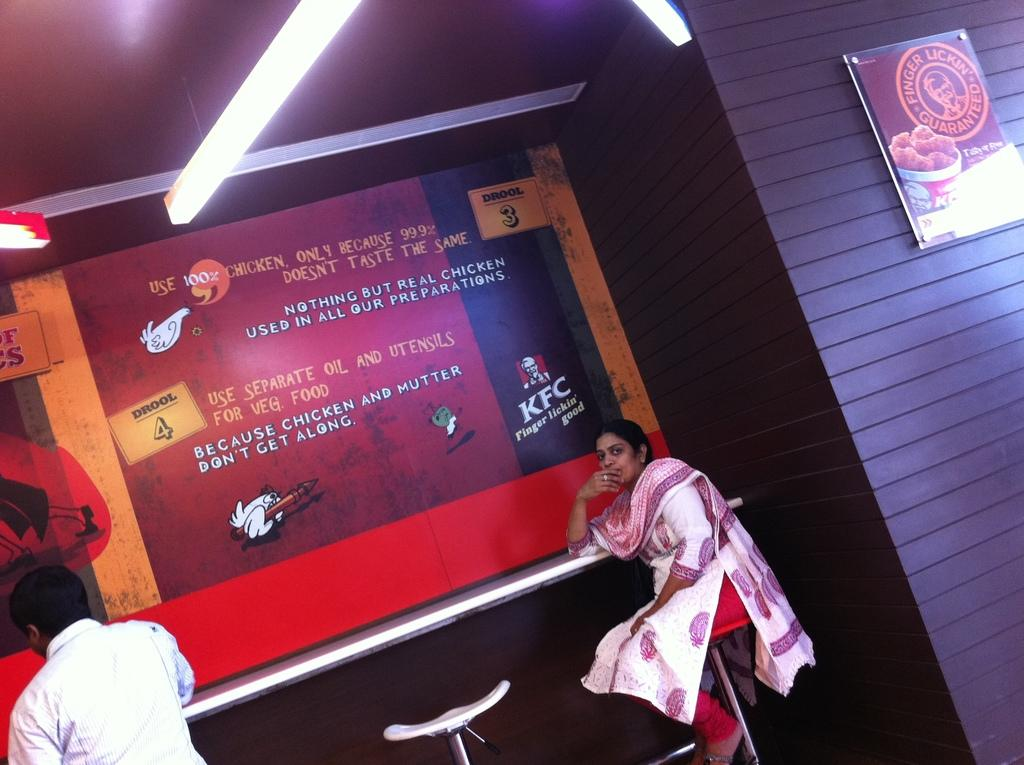<image>
Relay a brief, clear account of the picture shown. A women sets in front of a KFC poster. 